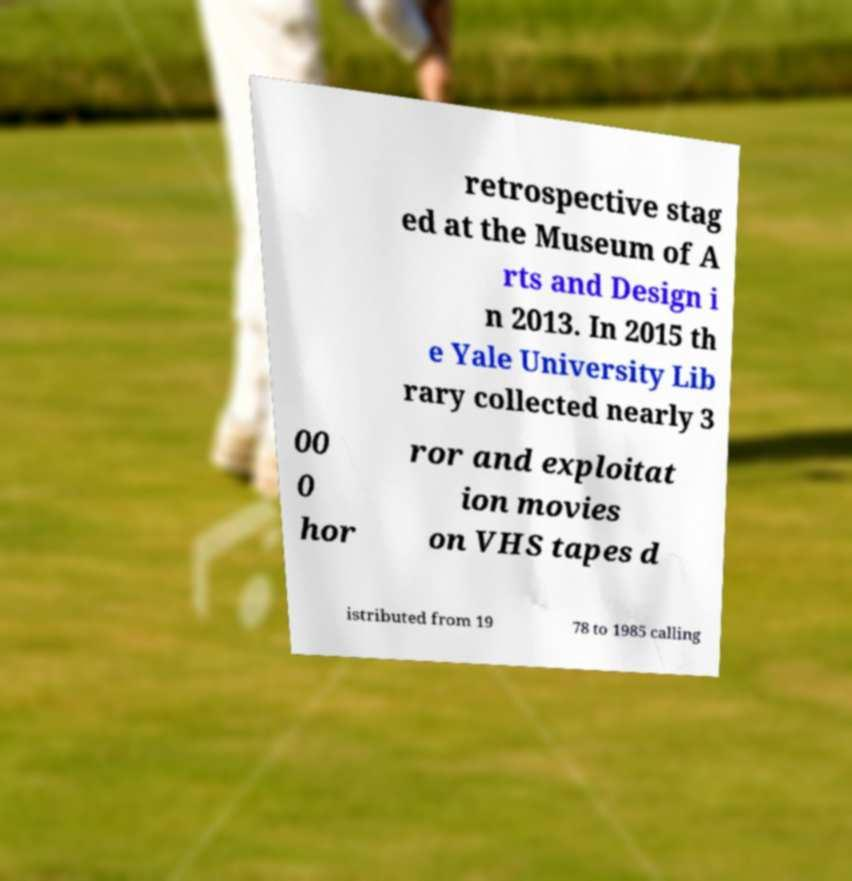Can you read and provide the text displayed in the image?This photo seems to have some interesting text. Can you extract and type it out for me? retrospective stag ed at the Museum of A rts and Design i n 2013. In 2015 th e Yale University Lib rary collected nearly 3 00 0 hor ror and exploitat ion movies on VHS tapes d istributed from 19 78 to 1985 calling 